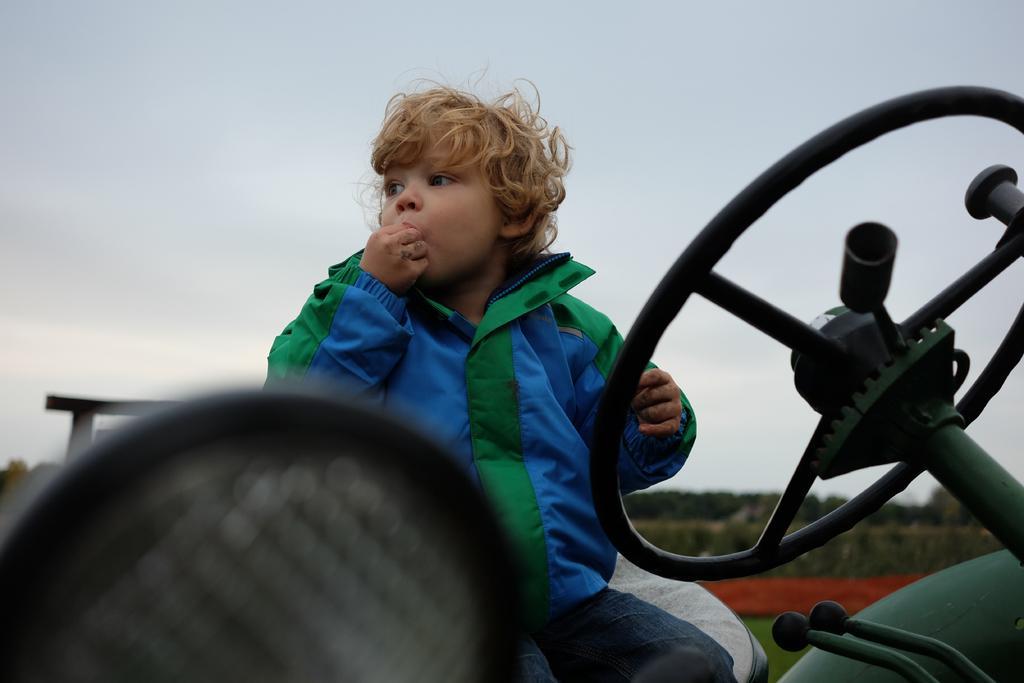Could you give a brief overview of what you see in this image? This boy is highlighted in this picture. He wore green and blue jacket. He is sitting on a vehicle. This is a steering in black color. Sky is in white color. This boy is eating, as we can see his hands are near to his mouth. Far there are number of plants. 